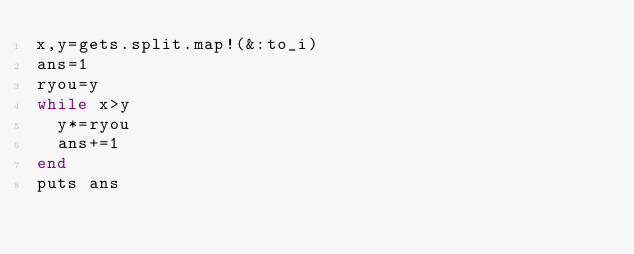<code> <loc_0><loc_0><loc_500><loc_500><_Ruby_>x,y=gets.split.map!(&:to_i)
ans=1
ryou=y
while x>y
  y*=ryou
  ans+=1
end
puts ans
</code> 